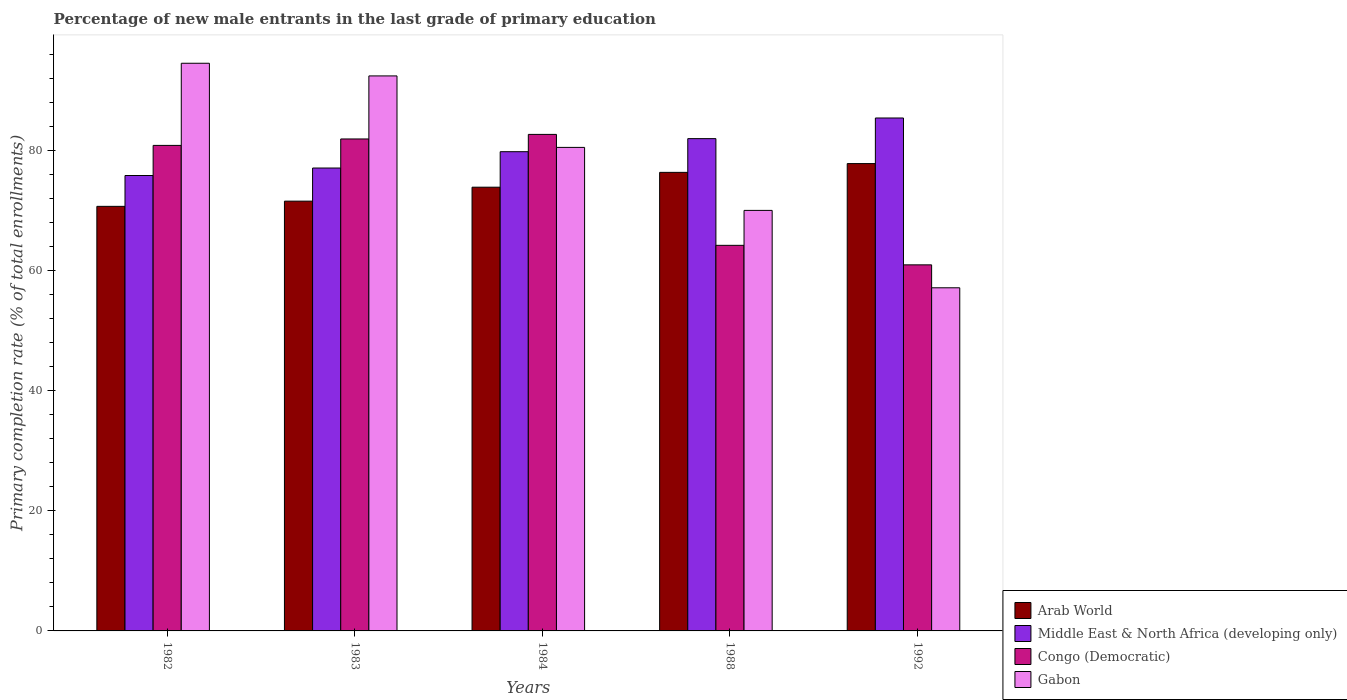How many different coloured bars are there?
Your answer should be compact. 4. How many groups of bars are there?
Offer a terse response. 5. Are the number of bars on each tick of the X-axis equal?
Offer a very short reply. Yes. How many bars are there on the 5th tick from the left?
Offer a terse response. 4. In how many cases, is the number of bars for a given year not equal to the number of legend labels?
Ensure brevity in your answer.  0. What is the percentage of new male entrants in Congo (Democratic) in 1983?
Your response must be concise. 81.88. Across all years, what is the maximum percentage of new male entrants in Gabon?
Ensure brevity in your answer.  94.48. Across all years, what is the minimum percentage of new male entrants in Arab World?
Make the answer very short. 70.67. In which year was the percentage of new male entrants in Gabon maximum?
Give a very brief answer. 1982. In which year was the percentage of new male entrants in Middle East & North Africa (developing only) minimum?
Make the answer very short. 1982. What is the total percentage of new male entrants in Gabon in the graph?
Provide a succinct answer. 394.44. What is the difference between the percentage of new male entrants in Congo (Democratic) in 1982 and that in 1988?
Provide a succinct answer. 16.63. What is the difference between the percentage of new male entrants in Congo (Democratic) in 1992 and the percentage of new male entrants in Middle East & North Africa (developing only) in 1983?
Keep it short and to the point. -16.12. What is the average percentage of new male entrants in Gabon per year?
Offer a very short reply. 78.89. In the year 1984, what is the difference between the percentage of new male entrants in Arab World and percentage of new male entrants in Gabon?
Give a very brief answer. -6.62. What is the ratio of the percentage of new male entrants in Arab World in 1983 to that in 1992?
Make the answer very short. 0.92. Is the difference between the percentage of new male entrants in Arab World in 1982 and 1992 greater than the difference between the percentage of new male entrants in Gabon in 1982 and 1992?
Offer a terse response. No. What is the difference between the highest and the second highest percentage of new male entrants in Gabon?
Offer a very short reply. 2.11. What is the difference between the highest and the lowest percentage of new male entrants in Arab World?
Your answer should be very brief. 7.12. Is it the case that in every year, the sum of the percentage of new male entrants in Middle East & North Africa (developing only) and percentage of new male entrants in Congo (Democratic) is greater than the sum of percentage of new male entrants in Gabon and percentage of new male entrants in Arab World?
Give a very brief answer. No. What does the 3rd bar from the left in 1982 represents?
Your response must be concise. Congo (Democratic). What does the 3rd bar from the right in 1983 represents?
Provide a succinct answer. Middle East & North Africa (developing only). What is the difference between two consecutive major ticks on the Y-axis?
Give a very brief answer. 20. Does the graph contain any zero values?
Make the answer very short. No. Does the graph contain grids?
Offer a very short reply. No. What is the title of the graph?
Make the answer very short. Percentage of new male entrants in the last grade of primary education. What is the label or title of the Y-axis?
Offer a terse response. Primary completion rate (% of total enrollments). What is the Primary completion rate (% of total enrollments) of Arab World in 1982?
Your answer should be very brief. 70.67. What is the Primary completion rate (% of total enrollments) of Middle East & North Africa (developing only) in 1982?
Offer a very short reply. 75.8. What is the Primary completion rate (% of total enrollments) in Congo (Democratic) in 1982?
Your response must be concise. 80.81. What is the Primary completion rate (% of total enrollments) of Gabon in 1982?
Provide a succinct answer. 94.48. What is the Primary completion rate (% of total enrollments) in Arab World in 1983?
Your answer should be very brief. 71.53. What is the Primary completion rate (% of total enrollments) in Middle East & North Africa (developing only) in 1983?
Your answer should be compact. 77.05. What is the Primary completion rate (% of total enrollments) in Congo (Democratic) in 1983?
Provide a short and direct response. 81.88. What is the Primary completion rate (% of total enrollments) of Gabon in 1983?
Offer a very short reply. 92.38. What is the Primary completion rate (% of total enrollments) of Arab World in 1984?
Provide a succinct answer. 73.85. What is the Primary completion rate (% of total enrollments) in Middle East & North Africa (developing only) in 1984?
Provide a short and direct response. 79.76. What is the Primary completion rate (% of total enrollments) in Congo (Democratic) in 1984?
Provide a short and direct response. 82.64. What is the Primary completion rate (% of total enrollments) in Gabon in 1984?
Keep it short and to the point. 80.48. What is the Primary completion rate (% of total enrollments) in Arab World in 1988?
Provide a short and direct response. 76.32. What is the Primary completion rate (% of total enrollments) in Middle East & North Africa (developing only) in 1988?
Provide a short and direct response. 81.94. What is the Primary completion rate (% of total enrollments) in Congo (Democratic) in 1988?
Ensure brevity in your answer.  64.18. What is the Primary completion rate (% of total enrollments) of Gabon in 1988?
Ensure brevity in your answer.  69.99. What is the Primary completion rate (% of total enrollments) of Arab World in 1992?
Your answer should be compact. 77.78. What is the Primary completion rate (% of total enrollments) in Middle East & North Africa (developing only) in 1992?
Your answer should be very brief. 85.37. What is the Primary completion rate (% of total enrollments) of Congo (Democratic) in 1992?
Provide a short and direct response. 60.93. What is the Primary completion rate (% of total enrollments) of Gabon in 1992?
Offer a terse response. 57.11. Across all years, what is the maximum Primary completion rate (% of total enrollments) in Arab World?
Provide a short and direct response. 77.78. Across all years, what is the maximum Primary completion rate (% of total enrollments) of Middle East & North Africa (developing only)?
Keep it short and to the point. 85.37. Across all years, what is the maximum Primary completion rate (% of total enrollments) of Congo (Democratic)?
Provide a short and direct response. 82.64. Across all years, what is the maximum Primary completion rate (% of total enrollments) in Gabon?
Make the answer very short. 94.48. Across all years, what is the minimum Primary completion rate (% of total enrollments) in Arab World?
Your response must be concise. 70.67. Across all years, what is the minimum Primary completion rate (% of total enrollments) of Middle East & North Africa (developing only)?
Your answer should be compact. 75.8. Across all years, what is the minimum Primary completion rate (% of total enrollments) in Congo (Democratic)?
Your answer should be very brief. 60.93. Across all years, what is the minimum Primary completion rate (% of total enrollments) in Gabon?
Offer a terse response. 57.11. What is the total Primary completion rate (% of total enrollments) of Arab World in the graph?
Provide a short and direct response. 370.16. What is the total Primary completion rate (% of total enrollments) of Middle East & North Africa (developing only) in the graph?
Keep it short and to the point. 399.92. What is the total Primary completion rate (% of total enrollments) in Congo (Democratic) in the graph?
Keep it short and to the point. 370.45. What is the total Primary completion rate (% of total enrollments) of Gabon in the graph?
Your response must be concise. 394.44. What is the difference between the Primary completion rate (% of total enrollments) in Arab World in 1982 and that in 1983?
Give a very brief answer. -0.87. What is the difference between the Primary completion rate (% of total enrollments) of Middle East & North Africa (developing only) in 1982 and that in 1983?
Offer a terse response. -1.25. What is the difference between the Primary completion rate (% of total enrollments) of Congo (Democratic) in 1982 and that in 1983?
Your answer should be very brief. -1.07. What is the difference between the Primary completion rate (% of total enrollments) of Gabon in 1982 and that in 1983?
Offer a very short reply. 2.11. What is the difference between the Primary completion rate (% of total enrollments) of Arab World in 1982 and that in 1984?
Make the answer very short. -3.19. What is the difference between the Primary completion rate (% of total enrollments) of Middle East & North Africa (developing only) in 1982 and that in 1984?
Offer a very short reply. -3.96. What is the difference between the Primary completion rate (% of total enrollments) in Congo (Democratic) in 1982 and that in 1984?
Give a very brief answer. -1.83. What is the difference between the Primary completion rate (% of total enrollments) in Gabon in 1982 and that in 1984?
Provide a short and direct response. 14.01. What is the difference between the Primary completion rate (% of total enrollments) of Arab World in 1982 and that in 1988?
Your response must be concise. -5.66. What is the difference between the Primary completion rate (% of total enrollments) in Middle East & North Africa (developing only) in 1982 and that in 1988?
Give a very brief answer. -6.14. What is the difference between the Primary completion rate (% of total enrollments) in Congo (Democratic) in 1982 and that in 1988?
Give a very brief answer. 16.63. What is the difference between the Primary completion rate (% of total enrollments) in Gabon in 1982 and that in 1988?
Give a very brief answer. 24.49. What is the difference between the Primary completion rate (% of total enrollments) of Arab World in 1982 and that in 1992?
Your response must be concise. -7.12. What is the difference between the Primary completion rate (% of total enrollments) in Middle East & North Africa (developing only) in 1982 and that in 1992?
Your response must be concise. -9.57. What is the difference between the Primary completion rate (% of total enrollments) in Congo (Democratic) in 1982 and that in 1992?
Offer a very short reply. 19.88. What is the difference between the Primary completion rate (% of total enrollments) of Gabon in 1982 and that in 1992?
Your answer should be very brief. 37.37. What is the difference between the Primary completion rate (% of total enrollments) in Arab World in 1983 and that in 1984?
Provide a succinct answer. -2.32. What is the difference between the Primary completion rate (% of total enrollments) in Middle East & North Africa (developing only) in 1983 and that in 1984?
Offer a terse response. -2.72. What is the difference between the Primary completion rate (% of total enrollments) in Congo (Democratic) in 1983 and that in 1984?
Ensure brevity in your answer.  -0.76. What is the difference between the Primary completion rate (% of total enrollments) of Gabon in 1983 and that in 1984?
Make the answer very short. 11.9. What is the difference between the Primary completion rate (% of total enrollments) of Arab World in 1983 and that in 1988?
Ensure brevity in your answer.  -4.79. What is the difference between the Primary completion rate (% of total enrollments) in Middle East & North Africa (developing only) in 1983 and that in 1988?
Make the answer very short. -4.89. What is the difference between the Primary completion rate (% of total enrollments) in Congo (Democratic) in 1983 and that in 1988?
Your response must be concise. 17.7. What is the difference between the Primary completion rate (% of total enrollments) in Gabon in 1983 and that in 1988?
Your response must be concise. 22.38. What is the difference between the Primary completion rate (% of total enrollments) of Arab World in 1983 and that in 1992?
Offer a terse response. -6.25. What is the difference between the Primary completion rate (% of total enrollments) in Middle East & North Africa (developing only) in 1983 and that in 1992?
Keep it short and to the point. -8.33. What is the difference between the Primary completion rate (% of total enrollments) of Congo (Democratic) in 1983 and that in 1992?
Make the answer very short. 20.95. What is the difference between the Primary completion rate (% of total enrollments) in Gabon in 1983 and that in 1992?
Give a very brief answer. 35.26. What is the difference between the Primary completion rate (% of total enrollments) in Arab World in 1984 and that in 1988?
Keep it short and to the point. -2.47. What is the difference between the Primary completion rate (% of total enrollments) in Middle East & North Africa (developing only) in 1984 and that in 1988?
Your answer should be very brief. -2.17. What is the difference between the Primary completion rate (% of total enrollments) in Congo (Democratic) in 1984 and that in 1988?
Offer a terse response. 18.46. What is the difference between the Primary completion rate (% of total enrollments) in Gabon in 1984 and that in 1988?
Make the answer very short. 10.48. What is the difference between the Primary completion rate (% of total enrollments) of Arab World in 1984 and that in 1992?
Make the answer very short. -3.93. What is the difference between the Primary completion rate (% of total enrollments) in Middle East & North Africa (developing only) in 1984 and that in 1992?
Offer a terse response. -5.61. What is the difference between the Primary completion rate (% of total enrollments) in Congo (Democratic) in 1984 and that in 1992?
Provide a succinct answer. 21.71. What is the difference between the Primary completion rate (% of total enrollments) of Gabon in 1984 and that in 1992?
Offer a terse response. 23.37. What is the difference between the Primary completion rate (% of total enrollments) in Arab World in 1988 and that in 1992?
Provide a succinct answer. -1.46. What is the difference between the Primary completion rate (% of total enrollments) in Middle East & North Africa (developing only) in 1988 and that in 1992?
Ensure brevity in your answer.  -3.44. What is the difference between the Primary completion rate (% of total enrollments) in Congo (Democratic) in 1988 and that in 1992?
Your answer should be very brief. 3.25. What is the difference between the Primary completion rate (% of total enrollments) of Gabon in 1988 and that in 1992?
Provide a succinct answer. 12.88. What is the difference between the Primary completion rate (% of total enrollments) in Arab World in 1982 and the Primary completion rate (% of total enrollments) in Middle East & North Africa (developing only) in 1983?
Offer a very short reply. -6.38. What is the difference between the Primary completion rate (% of total enrollments) of Arab World in 1982 and the Primary completion rate (% of total enrollments) of Congo (Democratic) in 1983?
Your answer should be very brief. -11.22. What is the difference between the Primary completion rate (% of total enrollments) in Arab World in 1982 and the Primary completion rate (% of total enrollments) in Gabon in 1983?
Make the answer very short. -21.71. What is the difference between the Primary completion rate (% of total enrollments) of Middle East & North Africa (developing only) in 1982 and the Primary completion rate (% of total enrollments) of Congo (Democratic) in 1983?
Provide a short and direct response. -6.08. What is the difference between the Primary completion rate (% of total enrollments) in Middle East & North Africa (developing only) in 1982 and the Primary completion rate (% of total enrollments) in Gabon in 1983?
Your answer should be compact. -16.58. What is the difference between the Primary completion rate (% of total enrollments) in Congo (Democratic) in 1982 and the Primary completion rate (% of total enrollments) in Gabon in 1983?
Give a very brief answer. -11.56. What is the difference between the Primary completion rate (% of total enrollments) of Arab World in 1982 and the Primary completion rate (% of total enrollments) of Middle East & North Africa (developing only) in 1984?
Offer a terse response. -9.1. What is the difference between the Primary completion rate (% of total enrollments) in Arab World in 1982 and the Primary completion rate (% of total enrollments) in Congo (Democratic) in 1984?
Offer a very short reply. -11.98. What is the difference between the Primary completion rate (% of total enrollments) in Arab World in 1982 and the Primary completion rate (% of total enrollments) in Gabon in 1984?
Give a very brief answer. -9.81. What is the difference between the Primary completion rate (% of total enrollments) of Middle East & North Africa (developing only) in 1982 and the Primary completion rate (% of total enrollments) of Congo (Democratic) in 1984?
Ensure brevity in your answer.  -6.84. What is the difference between the Primary completion rate (% of total enrollments) in Middle East & North Africa (developing only) in 1982 and the Primary completion rate (% of total enrollments) in Gabon in 1984?
Offer a terse response. -4.68. What is the difference between the Primary completion rate (% of total enrollments) in Congo (Democratic) in 1982 and the Primary completion rate (% of total enrollments) in Gabon in 1984?
Ensure brevity in your answer.  0.33. What is the difference between the Primary completion rate (% of total enrollments) of Arab World in 1982 and the Primary completion rate (% of total enrollments) of Middle East & North Africa (developing only) in 1988?
Offer a terse response. -11.27. What is the difference between the Primary completion rate (% of total enrollments) in Arab World in 1982 and the Primary completion rate (% of total enrollments) in Congo (Democratic) in 1988?
Provide a short and direct response. 6.49. What is the difference between the Primary completion rate (% of total enrollments) in Arab World in 1982 and the Primary completion rate (% of total enrollments) in Gabon in 1988?
Ensure brevity in your answer.  0.67. What is the difference between the Primary completion rate (% of total enrollments) in Middle East & North Africa (developing only) in 1982 and the Primary completion rate (% of total enrollments) in Congo (Democratic) in 1988?
Your answer should be compact. 11.62. What is the difference between the Primary completion rate (% of total enrollments) in Middle East & North Africa (developing only) in 1982 and the Primary completion rate (% of total enrollments) in Gabon in 1988?
Your response must be concise. 5.81. What is the difference between the Primary completion rate (% of total enrollments) of Congo (Democratic) in 1982 and the Primary completion rate (% of total enrollments) of Gabon in 1988?
Your answer should be very brief. 10.82. What is the difference between the Primary completion rate (% of total enrollments) in Arab World in 1982 and the Primary completion rate (% of total enrollments) in Middle East & North Africa (developing only) in 1992?
Your answer should be compact. -14.71. What is the difference between the Primary completion rate (% of total enrollments) in Arab World in 1982 and the Primary completion rate (% of total enrollments) in Congo (Democratic) in 1992?
Your response must be concise. 9.74. What is the difference between the Primary completion rate (% of total enrollments) in Arab World in 1982 and the Primary completion rate (% of total enrollments) in Gabon in 1992?
Your answer should be compact. 13.56. What is the difference between the Primary completion rate (% of total enrollments) in Middle East & North Africa (developing only) in 1982 and the Primary completion rate (% of total enrollments) in Congo (Democratic) in 1992?
Give a very brief answer. 14.87. What is the difference between the Primary completion rate (% of total enrollments) of Middle East & North Africa (developing only) in 1982 and the Primary completion rate (% of total enrollments) of Gabon in 1992?
Make the answer very short. 18.69. What is the difference between the Primary completion rate (% of total enrollments) of Congo (Democratic) in 1982 and the Primary completion rate (% of total enrollments) of Gabon in 1992?
Your answer should be very brief. 23.7. What is the difference between the Primary completion rate (% of total enrollments) of Arab World in 1983 and the Primary completion rate (% of total enrollments) of Middle East & North Africa (developing only) in 1984?
Provide a succinct answer. -8.23. What is the difference between the Primary completion rate (% of total enrollments) in Arab World in 1983 and the Primary completion rate (% of total enrollments) in Congo (Democratic) in 1984?
Make the answer very short. -11.11. What is the difference between the Primary completion rate (% of total enrollments) in Arab World in 1983 and the Primary completion rate (% of total enrollments) in Gabon in 1984?
Ensure brevity in your answer.  -8.94. What is the difference between the Primary completion rate (% of total enrollments) in Middle East & North Africa (developing only) in 1983 and the Primary completion rate (% of total enrollments) in Congo (Democratic) in 1984?
Offer a very short reply. -5.6. What is the difference between the Primary completion rate (% of total enrollments) in Middle East & North Africa (developing only) in 1983 and the Primary completion rate (% of total enrollments) in Gabon in 1984?
Your answer should be very brief. -3.43. What is the difference between the Primary completion rate (% of total enrollments) in Congo (Democratic) in 1983 and the Primary completion rate (% of total enrollments) in Gabon in 1984?
Offer a terse response. 1.41. What is the difference between the Primary completion rate (% of total enrollments) of Arab World in 1983 and the Primary completion rate (% of total enrollments) of Middle East & North Africa (developing only) in 1988?
Your response must be concise. -10.4. What is the difference between the Primary completion rate (% of total enrollments) of Arab World in 1983 and the Primary completion rate (% of total enrollments) of Congo (Democratic) in 1988?
Give a very brief answer. 7.35. What is the difference between the Primary completion rate (% of total enrollments) in Arab World in 1983 and the Primary completion rate (% of total enrollments) in Gabon in 1988?
Ensure brevity in your answer.  1.54. What is the difference between the Primary completion rate (% of total enrollments) in Middle East & North Africa (developing only) in 1983 and the Primary completion rate (% of total enrollments) in Congo (Democratic) in 1988?
Provide a short and direct response. 12.87. What is the difference between the Primary completion rate (% of total enrollments) of Middle East & North Africa (developing only) in 1983 and the Primary completion rate (% of total enrollments) of Gabon in 1988?
Your answer should be compact. 7.05. What is the difference between the Primary completion rate (% of total enrollments) in Congo (Democratic) in 1983 and the Primary completion rate (% of total enrollments) in Gabon in 1988?
Your response must be concise. 11.89. What is the difference between the Primary completion rate (% of total enrollments) in Arab World in 1983 and the Primary completion rate (% of total enrollments) in Middle East & North Africa (developing only) in 1992?
Make the answer very short. -13.84. What is the difference between the Primary completion rate (% of total enrollments) of Arab World in 1983 and the Primary completion rate (% of total enrollments) of Congo (Democratic) in 1992?
Offer a very short reply. 10.6. What is the difference between the Primary completion rate (% of total enrollments) of Arab World in 1983 and the Primary completion rate (% of total enrollments) of Gabon in 1992?
Offer a very short reply. 14.42. What is the difference between the Primary completion rate (% of total enrollments) in Middle East & North Africa (developing only) in 1983 and the Primary completion rate (% of total enrollments) in Congo (Democratic) in 1992?
Ensure brevity in your answer.  16.12. What is the difference between the Primary completion rate (% of total enrollments) of Middle East & North Africa (developing only) in 1983 and the Primary completion rate (% of total enrollments) of Gabon in 1992?
Provide a short and direct response. 19.94. What is the difference between the Primary completion rate (% of total enrollments) of Congo (Democratic) in 1983 and the Primary completion rate (% of total enrollments) of Gabon in 1992?
Ensure brevity in your answer.  24.77. What is the difference between the Primary completion rate (% of total enrollments) of Arab World in 1984 and the Primary completion rate (% of total enrollments) of Middle East & North Africa (developing only) in 1988?
Provide a succinct answer. -8.08. What is the difference between the Primary completion rate (% of total enrollments) in Arab World in 1984 and the Primary completion rate (% of total enrollments) in Congo (Democratic) in 1988?
Give a very brief answer. 9.68. What is the difference between the Primary completion rate (% of total enrollments) in Arab World in 1984 and the Primary completion rate (% of total enrollments) in Gabon in 1988?
Provide a succinct answer. 3.86. What is the difference between the Primary completion rate (% of total enrollments) of Middle East & North Africa (developing only) in 1984 and the Primary completion rate (% of total enrollments) of Congo (Democratic) in 1988?
Provide a succinct answer. 15.58. What is the difference between the Primary completion rate (% of total enrollments) in Middle East & North Africa (developing only) in 1984 and the Primary completion rate (% of total enrollments) in Gabon in 1988?
Give a very brief answer. 9.77. What is the difference between the Primary completion rate (% of total enrollments) in Congo (Democratic) in 1984 and the Primary completion rate (% of total enrollments) in Gabon in 1988?
Ensure brevity in your answer.  12.65. What is the difference between the Primary completion rate (% of total enrollments) of Arab World in 1984 and the Primary completion rate (% of total enrollments) of Middle East & North Africa (developing only) in 1992?
Your answer should be very brief. -11.52. What is the difference between the Primary completion rate (% of total enrollments) of Arab World in 1984 and the Primary completion rate (% of total enrollments) of Congo (Democratic) in 1992?
Your answer should be compact. 12.93. What is the difference between the Primary completion rate (% of total enrollments) in Arab World in 1984 and the Primary completion rate (% of total enrollments) in Gabon in 1992?
Your answer should be very brief. 16.74. What is the difference between the Primary completion rate (% of total enrollments) in Middle East & North Africa (developing only) in 1984 and the Primary completion rate (% of total enrollments) in Congo (Democratic) in 1992?
Make the answer very short. 18.83. What is the difference between the Primary completion rate (% of total enrollments) in Middle East & North Africa (developing only) in 1984 and the Primary completion rate (% of total enrollments) in Gabon in 1992?
Make the answer very short. 22.65. What is the difference between the Primary completion rate (% of total enrollments) in Congo (Democratic) in 1984 and the Primary completion rate (% of total enrollments) in Gabon in 1992?
Your answer should be compact. 25.53. What is the difference between the Primary completion rate (% of total enrollments) of Arab World in 1988 and the Primary completion rate (% of total enrollments) of Middle East & North Africa (developing only) in 1992?
Provide a short and direct response. -9.05. What is the difference between the Primary completion rate (% of total enrollments) of Arab World in 1988 and the Primary completion rate (% of total enrollments) of Congo (Democratic) in 1992?
Ensure brevity in your answer.  15.39. What is the difference between the Primary completion rate (% of total enrollments) in Arab World in 1988 and the Primary completion rate (% of total enrollments) in Gabon in 1992?
Keep it short and to the point. 19.21. What is the difference between the Primary completion rate (% of total enrollments) of Middle East & North Africa (developing only) in 1988 and the Primary completion rate (% of total enrollments) of Congo (Democratic) in 1992?
Offer a terse response. 21.01. What is the difference between the Primary completion rate (% of total enrollments) in Middle East & North Africa (developing only) in 1988 and the Primary completion rate (% of total enrollments) in Gabon in 1992?
Your response must be concise. 24.83. What is the difference between the Primary completion rate (% of total enrollments) in Congo (Democratic) in 1988 and the Primary completion rate (% of total enrollments) in Gabon in 1992?
Keep it short and to the point. 7.07. What is the average Primary completion rate (% of total enrollments) of Arab World per year?
Make the answer very short. 74.03. What is the average Primary completion rate (% of total enrollments) in Middle East & North Africa (developing only) per year?
Provide a succinct answer. 79.98. What is the average Primary completion rate (% of total enrollments) of Congo (Democratic) per year?
Your answer should be compact. 74.09. What is the average Primary completion rate (% of total enrollments) of Gabon per year?
Your answer should be very brief. 78.89. In the year 1982, what is the difference between the Primary completion rate (% of total enrollments) in Arab World and Primary completion rate (% of total enrollments) in Middle East & North Africa (developing only)?
Give a very brief answer. -5.13. In the year 1982, what is the difference between the Primary completion rate (% of total enrollments) in Arab World and Primary completion rate (% of total enrollments) in Congo (Democratic)?
Offer a very short reply. -10.14. In the year 1982, what is the difference between the Primary completion rate (% of total enrollments) of Arab World and Primary completion rate (% of total enrollments) of Gabon?
Offer a terse response. -23.82. In the year 1982, what is the difference between the Primary completion rate (% of total enrollments) of Middle East & North Africa (developing only) and Primary completion rate (% of total enrollments) of Congo (Democratic)?
Your response must be concise. -5.01. In the year 1982, what is the difference between the Primary completion rate (% of total enrollments) in Middle East & North Africa (developing only) and Primary completion rate (% of total enrollments) in Gabon?
Give a very brief answer. -18.68. In the year 1982, what is the difference between the Primary completion rate (% of total enrollments) in Congo (Democratic) and Primary completion rate (% of total enrollments) in Gabon?
Ensure brevity in your answer.  -13.67. In the year 1983, what is the difference between the Primary completion rate (% of total enrollments) of Arab World and Primary completion rate (% of total enrollments) of Middle East & North Africa (developing only)?
Provide a succinct answer. -5.51. In the year 1983, what is the difference between the Primary completion rate (% of total enrollments) in Arab World and Primary completion rate (% of total enrollments) in Congo (Democratic)?
Keep it short and to the point. -10.35. In the year 1983, what is the difference between the Primary completion rate (% of total enrollments) in Arab World and Primary completion rate (% of total enrollments) in Gabon?
Keep it short and to the point. -20.84. In the year 1983, what is the difference between the Primary completion rate (% of total enrollments) of Middle East & North Africa (developing only) and Primary completion rate (% of total enrollments) of Congo (Democratic)?
Give a very brief answer. -4.84. In the year 1983, what is the difference between the Primary completion rate (% of total enrollments) of Middle East & North Africa (developing only) and Primary completion rate (% of total enrollments) of Gabon?
Offer a terse response. -15.33. In the year 1983, what is the difference between the Primary completion rate (% of total enrollments) of Congo (Democratic) and Primary completion rate (% of total enrollments) of Gabon?
Offer a terse response. -10.49. In the year 1984, what is the difference between the Primary completion rate (% of total enrollments) in Arab World and Primary completion rate (% of total enrollments) in Middle East & North Africa (developing only)?
Keep it short and to the point. -5.91. In the year 1984, what is the difference between the Primary completion rate (% of total enrollments) in Arab World and Primary completion rate (% of total enrollments) in Congo (Democratic)?
Provide a short and direct response. -8.79. In the year 1984, what is the difference between the Primary completion rate (% of total enrollments) in Arab World and Primary completion rate (% of total enrollments) in Gabon?
Your response must be concise. -6.62. In the year 1984, what is the difference between the Primary completion rate (% of total enrollments) of Middle East & North Africa (developing only) and Primary completion rate (% of total enrollments) of Congo (Democratic)?
Keep it short and to the point. -2.88. In the year 1984, what is the difference between the Primary completion rate (% of total enrollments) of Middle East & North Africa (developing only) and Primary completion rate (% of total enrollments) of Gabon?
Ensure brevity in your answer.  -0.72. In the year 1984, what is the difference between the Primary completion rate (% of total enrollments) in Congo (Democratic) and Primary completion rate (% of total enrollments) in Gabon?
Make the answer very short. 2.17. In the year 1988, what is the difference between the Primary completion rate (% of total enrollments) in Arab World and Primary completion rate (% of total enrollments) in Middle East & North Africa (developing only)?
Your response must be concise. -5.61. In the year 1988, what is the difference between the Primary completion rate (% of total enrollments) in Arab World and Primary completion rate (% of total enrollments) in Congo (Democratic)?
Give a very brief answer. 12.14. In the year 1988, what is the difference between the Primary completion rate (% of total enrollments) in Arab World and Primary completion rate (% of total enrollments) in Gabon?
Your answer should be very brief. 6.33. In the year 1988, what is the difference between the Primary completion rate (% of total enrollments) in Middle East & North Africa (developing only) and Primary completion rate (% of total enrollments) in Congo (Democratic)?
Your response must be concise. 17.76. In the year 1988, what is the difference between the Primary completion rate (% of total enrollments) in Middle East & North Africa (developing only) and Primary completion rate (% of total enrollments) in Gabon?
Your answer should be very brief. 11.94. In the year 1988, what is the difference between the Primary completion rate (% of total enrollments) in Congo (Democratic) and Primary completion rate (% of total enrollments) in Gabon?
Provide a succinct answer. -5.81. In the year 1992, what is the difference between the Primary completion rate (% of total enrollments) of Arab World and Primary completion rate (% of total enrollments) of Middle East & North Africa (developing only)?
Provide a succinct answer. -7.59. In the year 1992, what is the difference between the Primary completion rate (% of total enrollments) in Arab World and Primary completion rate (% of total enrollments) in Congo (Democratic)?
Your response must be concise. 16.86. In the year 1992, what is the difference between the Primary completion rate (% of total enrollments) in Arab World and Primary completion rate (% of total enrollments) in Gabon?
Offer a very short reply. 20.67. In the year 1992, what is the difference between the Primary completion rate (% of total enrollments) in Middle East & North Africa (developing only) and Primary completion rate (% of total enrollments) in Congo (Democratic)?
Provide a succinct answer. 24.44. In the year 1992, what is the difference between the Primary completion rate (% of total enrollments) of Middle East & North Africa (developing only) and Primary completion rate (% of total enrollments) of Gabon?
Offer a terse response. 28.26. In the year 1992, what is the difference between the Primary completion rate (% of total enrollments) of Congo (Democratic) and Primary completion rate (% of total enrollments) of Gabon?
Provide a short and direct response. 3.82. What is the ratio of the Primary completion rate (% of total enrollments) of Arab World in 1982 to that in 1983?
Your response must be concise. 0.99. What is the ratio of the Primary completion rate (% of total enrollments) in Middle East & North Africa (developing only) in 1982 to that in 1983?
Your answer should be compact. 0.98. What is the ratio of the Primary completion rate (% of total enrollments) in Congo (Democratic) in 1982 to that in 1983?
Provide a short and direct response. 0.99. What is the ratio of the Primary completion rate (% of total enrollments) of Gabon in 1982 to that in 1983?
Your answer should be compact. 1.02. What is the ratio of the Primary completion rate (% of total enrollments) of Arab World in 1982 to that in 1984?
Your answer should be very brief. 0.96. What is the ratio of the Primary completion rate (% of total enrollments) in Middle East & North Africa (developing only) in 1982 to that in 1984?
Keep it short and to the point. 0.95. What is the ratio of the Primary completion rate (% of total enrollments) in Congo (Democratic) in 1982 to that in 1984?
Ensure brevity in your answer.  0.98. What is the ratio of the Primary completion rate (% of total enrollments) of Gabon in 1982 to that in 1984?
Provide a short and direct response. 1.17. What is the ratio of the Primary completion rate (% of total enrollments) in Arab World in 1982 to that in 1988?
Provide a short and direct response. 0.93. What is the ratio of the Primary completion rate (% of total enrollments) in Middle East & North Africa (developing only) in 1982 to that in 1988?
Your answer should be compact. 0.93. What is the ratio of the Primary completion rate (% of total enrollments) in Congo (Democratic) in 1982 to that in 1988?
Make the answer very short. 1.26. What is the ratio of the Primary completion rate (% of total enrollments) in Gabon in 1982 to that in 1988?
Give a very brief answer. 1.35. What is the ratio of the Primary completion rate (% of total enrollments) of Arab World in 1982 to that in 1992?
Make the answer very short. 0.91. What is the ratio of the Primary completion rate (% of total enrollments) of Middle East & North Africa (developing only) in 1982 to that in 1992?
Keep it short and to the point. 0.89. What is the ratio of the Primary completion rate (% of total enrollments) in Congo (Democratic) in 1982 to that in 1992?
Make the answer very short. 1.33. What is the ratio of the Primary completion rate (% of total enrollments) in Gabon in 1982 to that in 1992?
Make the answer very short. 1.65. What is the ratio of the Primary completion rate (% of total enrollments) of Arab World in 1983 to that in 1984?
Give a very brief answer. 0.97. What is the ratio of the Primary completion rate (% of total enrollments) of Congo (Democratic) in 1983 to that in 1984?
Offer a terse response. 0.99. What is the ratio of the Primary completion rate (% of total enrollments) in Gabon in 1983 to that in 1984?
Make the answer very short. 1.15. What is the ratio of the Primary completion rate (% of total enrollments) of Arab World in 1983 to that in 1988?
Make the answer very short. 0.94. What is the ratio of the Primary completion rate (% of total enrollments) of Middle East & North Africa (developing only) in 1983 to that in 1988?
Make the answer very short. 0.94. What is the ratio of the Primary completion rate (% of total enrollments) in Congo (Democratic) in 1983 to that in 1988?
Keep it short and to the point. 1.28. What is the ratio of the Primary completion rate (% of total enrollments) of Gabon in 1983 to that in 1988?
Offer a terse response. 1.32. What is the ratio of the Primary completion rate (% of total enrollments) of Arab World in 1983 to that in 1992?
Give a very brief answer. 0.92. What is the ratio of the Primary completion rate (% of total enrollments) in Middle East & North Africa (developing only) in 1983 to that in 1992?
Your answer should be very brief. 0.9. What is the ratio of the Primary completion rate (% of total enrollments) in Congo (Democratic) in 1983 to that in 1992?
Provide a succinct answer. 1.34. What is the ratio of the Primary completion rate (% of total enrollments) of Gabon in 1983 to that in 1992?
Keep it short and to the point. 1.62. What is the ratio of the Primary completion rate (% of total enrollments) in Arab World in 1984 to that in 1988?
Give a very brief answer. 0.97. What is the ratio of the Primary completion rate (% of total enrollments) in Middle East & North Africa (developing only) in 1984 to that in 1988?
Give a very brief answer. 0.97. What is the ratio of the Primary completion rate (% of total enrollments) of Congo (Democratic) in 1984 to that in 1988?
Keep it short and to the point. 1.29. What is the ratio of the Primary completion rate (% of total enrollments) in Gabon in 1984 to that in 1988?
Offer a very short reply. 1.15. What is the ratio of the Primary completion rate (% of total enrollments) in Arab World in 1984 to that in 1992?
Provide a succinct answer. 0.95. What is the ratio of the Primary completion rate (% of total enrollments) in Middle East & North Africa (developing only) in 1984 to that in 1992?
Keep it short and to the point. 0.93. What is the ratio of the Primary completion rate (% of total enrollments) of Congo (Democratic) in 1984 to that in 1992?
Your answer should be compact. 1.36. What is the ratio of the Primary completion rate (% of total enrollments) of Gabon in 1984 to that in 1992?
Your response must be concise. 1.41. What is the ratio of the Primary completion rate (% of total enrollments) in Arab World in 1988 to that in 1992?
Provide a short and direct response. 0.98. What is the ratio of the Primary completion rate (% of total enrollments) of Middle East & North Africa (developing only) in 1988 to that in 1992?
Offer a very short reply. 0.96. What is the ratio of the Primary completion rate (% of total enrollments) in Congo (Democratic) in 1988 to that in 1992?
Offer a very short reply. 1.05. What is the ratio of the Primary completion rate (% of total enrollments) of Gabon in 1988 to that in 1992?
Your response must be concise. 1.23. What is the difference between the highest and the second highest Primary completion rate (% of total enrollments) of Arab World?
Offer a terse response. 1.46. What is the difference between the highest and the second highest Primary completion rate (% of total enrollments) of Middle East & North Africa (developing only)?
Your answer should be compact. 3.44. What is the difference between the highest and the second highest Primary completion rate (% of total enrollments) in Congo (Democratic)?
Provide a succinct answer. 0.76. What is the difference between the highest and the second highest Primary completion rate (% of total enrollments) of Gabon?
Offer a terse response. 2.11. What is the difference between the highest and the lowest Primary completion rate (% of total enrollments) in Arab World?
Provide a succinct answer. 7.12. What is the difference between the highest and the lowest Primary completion rate (% of total enrollments) in Middle East & North Africa (developing only)?
Offer a very short reply. 9.57. What is the difference between the highest and the lowest Primary completion rate (% of total enrollments) of Congo (Democratic)?
Offer a terse response. 21.71. What is the difference between the highest and the lowest Primary completion rate (% of total enrollments) in Gabon?
Offer a terse response. 37.37. 